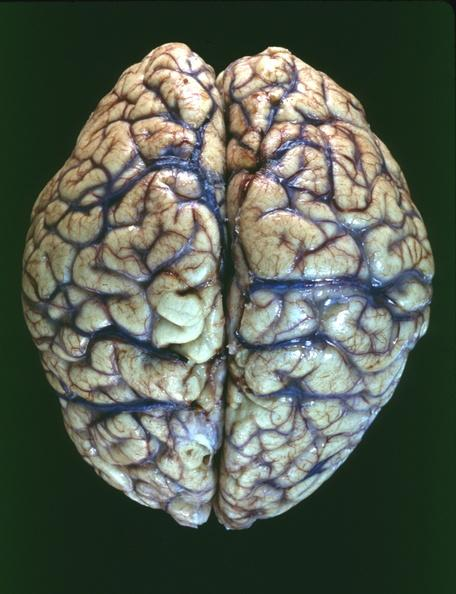what is present?
Answer the question using a single word or phrase. Nervous 